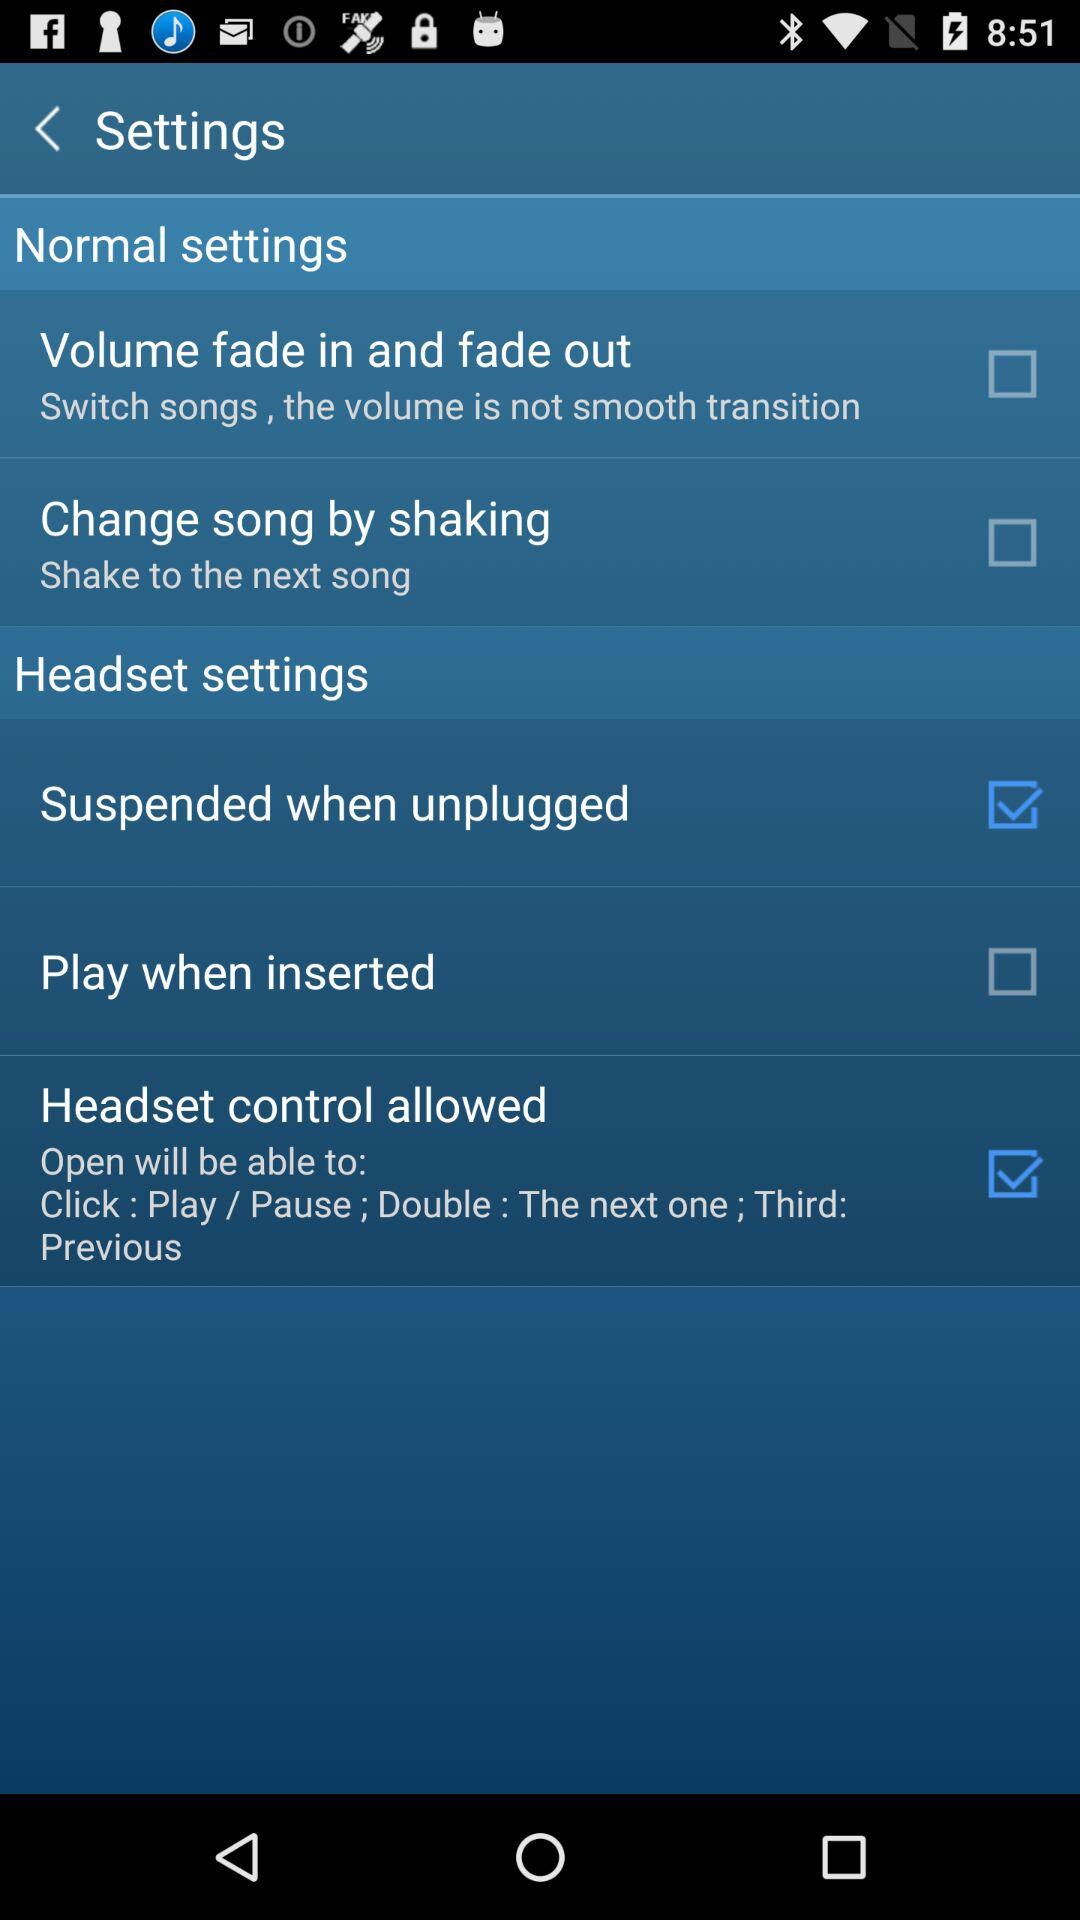What is the status of the "Headset control allowed"? The status is "on". 